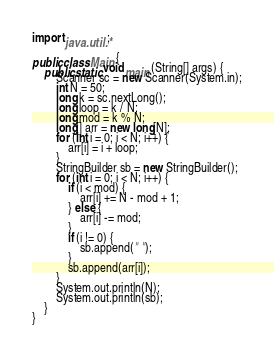<code> <loc_0><loc_0><loc_500><loc_500><_Java_>import java.util.*;

public class Main {
	public static void main (String[] args) {
		Scanner sc = new Scanner(System.in);
		int N = 50;
		long k = sc.nextLong();
		long loop = k / N;
		long mod = k % N;
		long[] arr = new long[N];
		for (int i = 0; i < N; i++) {
			arr[i] = i + loop;
		}
		StringBuilder sb = new StringBuilder();
		for (int i = 0; i < N; i++) {
			if (i < mod) {
				arr[i] += N - mod + 1;
			} else {
				arr[i] -= mod;
			}
			if (i != 0) {
				sb.append(" ");
			}
			sb.append(arr[i]);
		}
		System.out.println(N);
		System.out.println(sb);
	}
}
</code> 